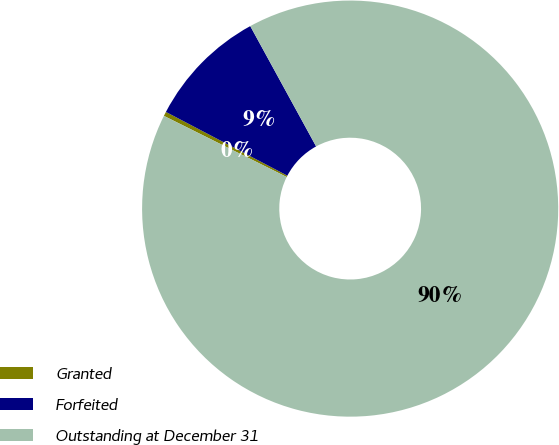Convert chart. <chart><loc_0><loc_0><loc_500><loc_500><pie_chart><fcel>Granted<fcel>Forfeited<fcel>Outstanding at December 31<nl><fcel>0.34%<fcel>9.34%<fcel>90.33%<nl></chart> 